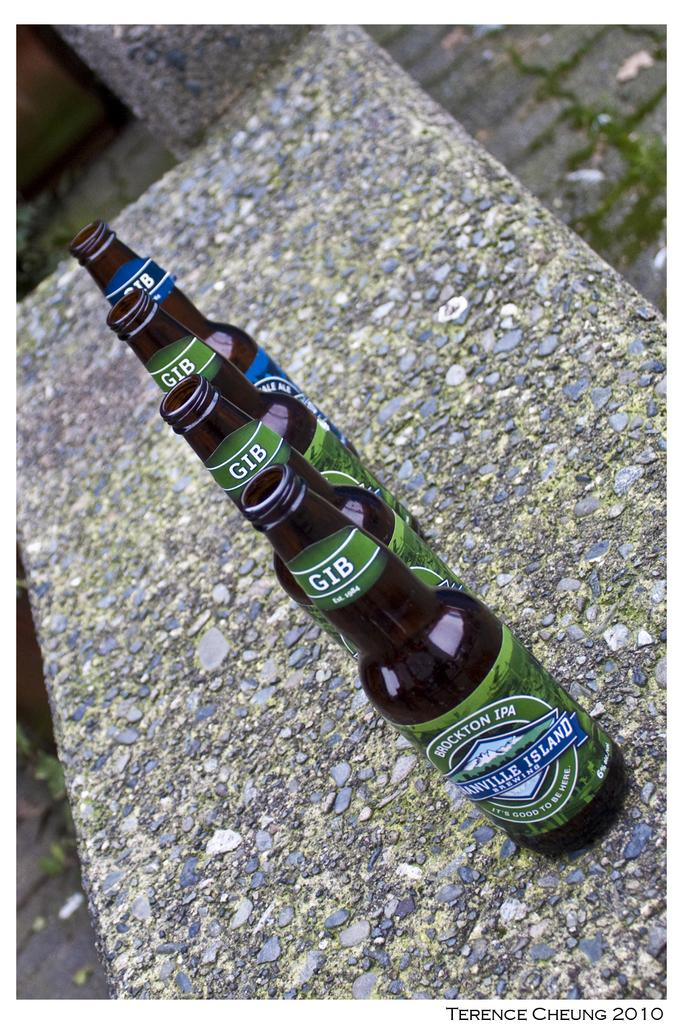<image>
Offer a succinct explanation of the picture presented. Brockton IPA is at the front of this line of beer bottles. 